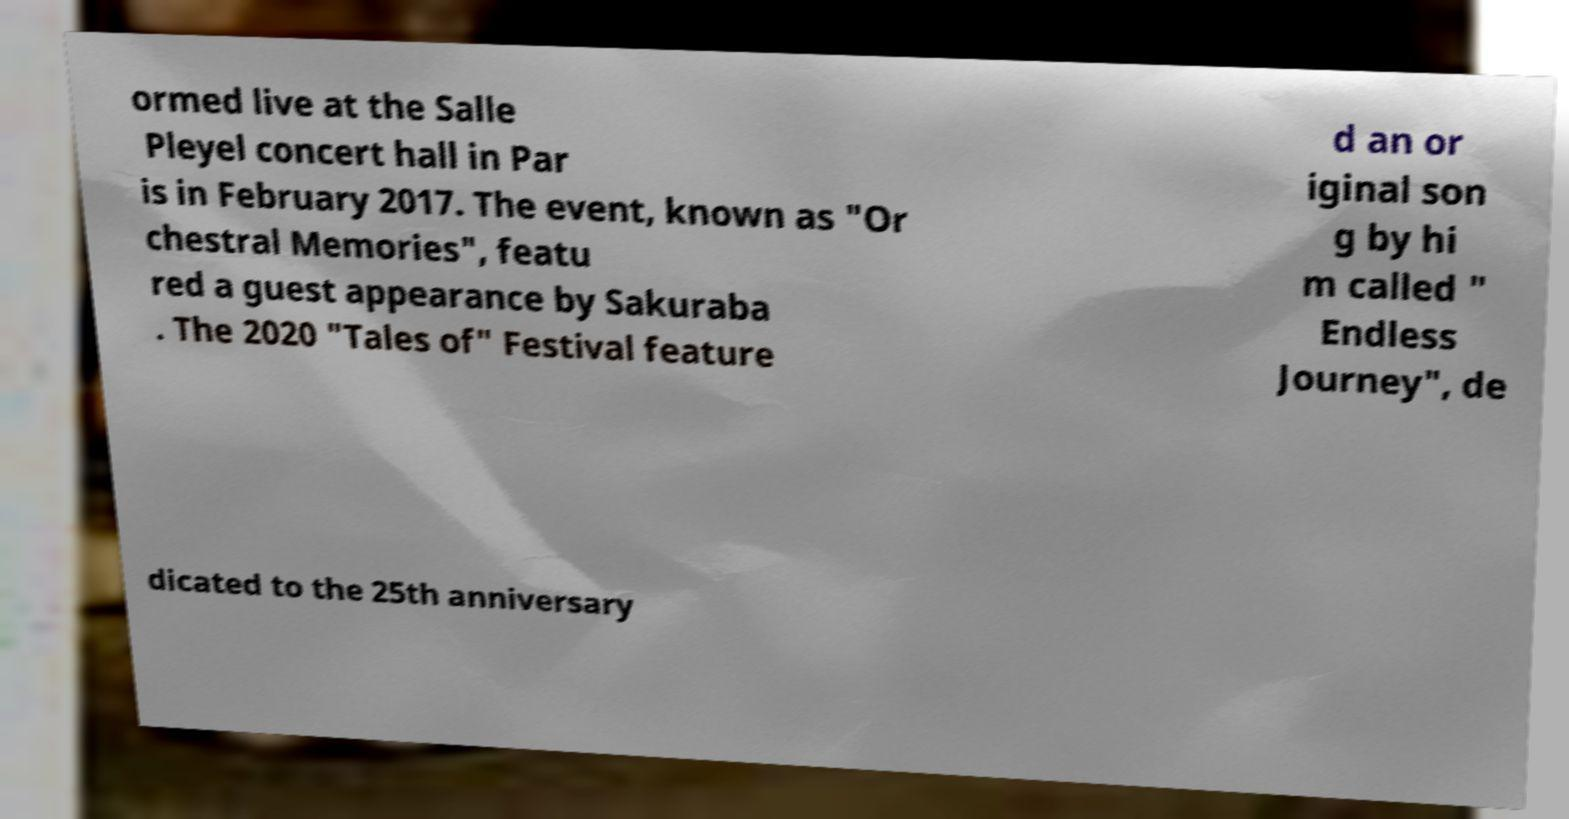Please read and relay the text visible in this image. What does it say? ormed live at the Salle Pleyel concert hall in Par is in February 2017. The event, known as "Or chestral Memories", featu red a guest appearance by Sakuraba . The 2020 "Tales of" Festival feature d an or iginal son g by hi m called " Endless Journey", de dicated to the 25th anniversary 